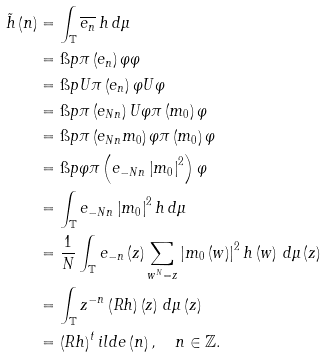Convert formula to latex. <formula><loc_0><loc_0><loc_500><loc_500>\tilde { h } \left ( n \right ) & = \int _ { \mathbb { T } } \overline { e _ { n } } \, h \, d \mu \\ & = \i p { \pi \left ( e _ { n } \right ) \varphi } { \varphi } \\ & = \i p { U \pi \left ( e _ { n } \right ) \varphi } { U \varphi } \\ & = \i p { \pi \left ( e _ { N n } \right ) U \varphi } { \pi \left ( m _ { 0 } \right ) \varphi } \\ & = \i p { \pi \left ( e _ { N n } m _ { 0 } \right ) \varphi } { \pi \left ( m _ { 0 } \right ) \varphi } \\ & = \i p { \varphi } { \pi \left ( e _ { - N n } \left | m _ { 0 } \right | ^ { 2 } \right ) \varphi } \\ & = \int _ { \mathbb { T } } e _ { - N n } \left | m _ { 0 } \right | ^ { 2 } h \, d \mu \\ & = \frac { 1 } { N } \int _ { \mathbb { T } } e _ { - n } \left ( z \right ) \sum _ { w ^ { N } = z } \left | m _ { 0 } \left ( w \right ) \right | ^ { 2 } h \left ( w \right ) \, d \mu \left ( z \right ) \\ & = \int _ { \mathbb { T } } z ^ { - n } \left ( R h \right ) \left ( z \right ) \, d \mu \left ( z \right ) \\ & = \left ( R h \right ) ^ { t } i l d e \left ( n \right ) , \quad n \in \mathbb { Z } .</formula> 